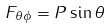<formula> <loc_0><loc_0><loc_500><loc_500>F _ { \theta \phi } = P \sin \theta \</formula> 